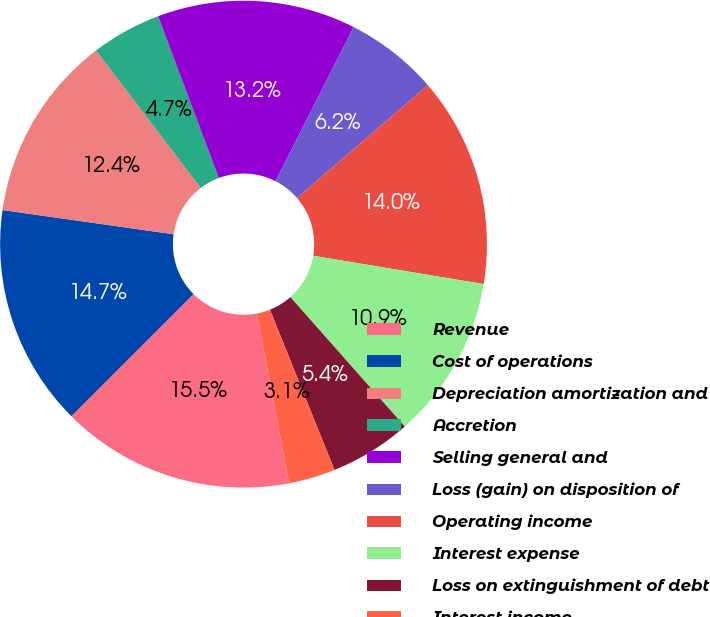Convert chart to OTSL. <chart><loc_0><loc_0><loc_500><loc_500><pie_chart><fcel>Revenue<fcel>Cost of operations<fcel>Depreciation amortization and<fcel>Accretion<fcel>Selling general and<fcel>Loss (gain) on disposition of<fcel>Operating income<fcel>Interest expense<fcel>Loss on extinguishment of debt<fcel>Interest income<nl><fcel>15.5%<fcel>14.73%<fcel>12.4%<fcel>4.65%<fcel>13.18%<fcel>6.2%<fcel>13.95%<fcel>10.85%<fcel>5.43%<fcel>3.1%<nl></chart> 